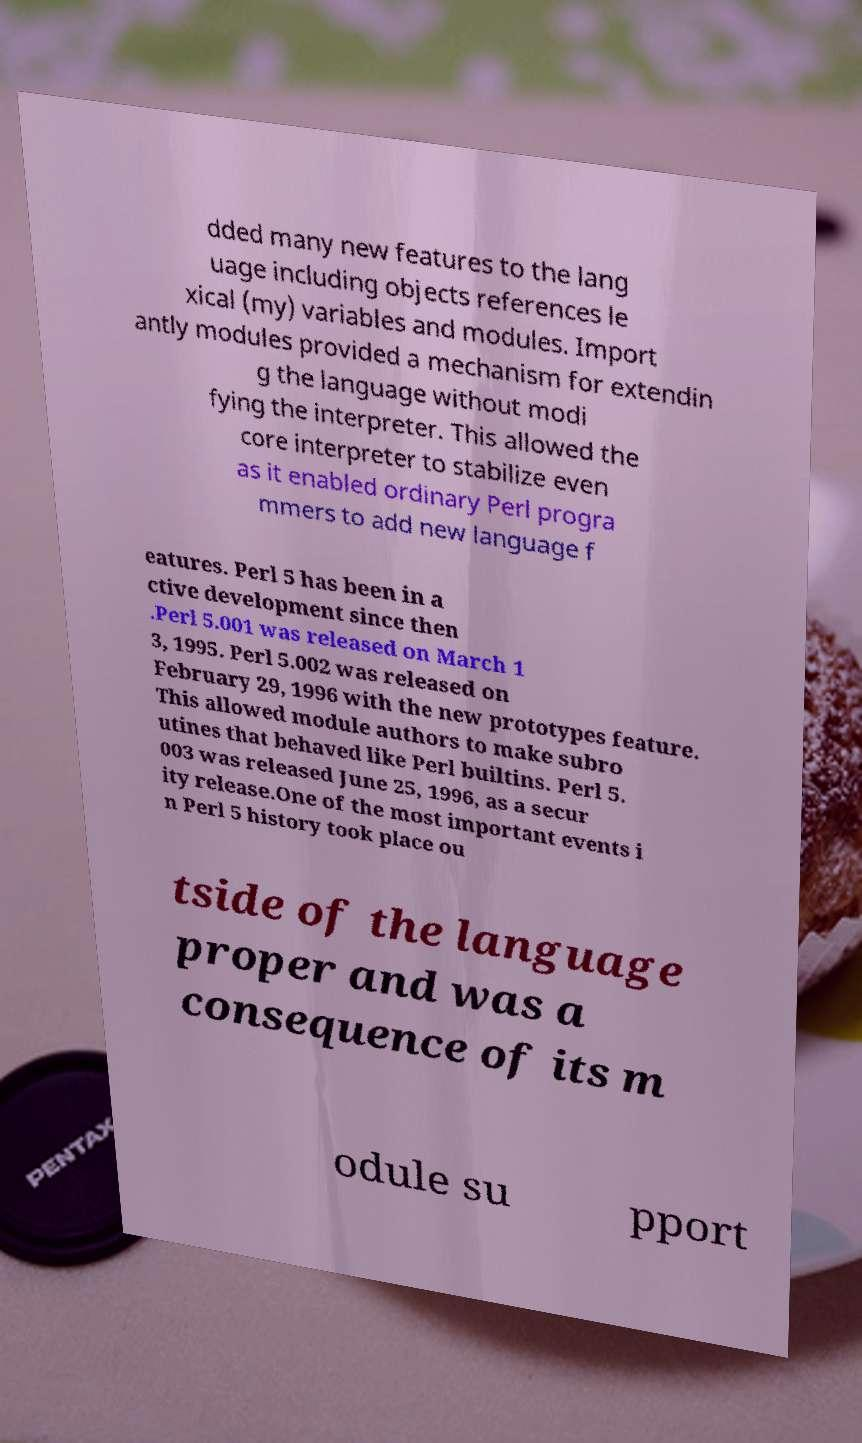I need the written content from this picture converted into text. Can you do that? dded many new features to the lang uage including objects references le xical (my) variables and modules. Import antly modules provided a mechanism for extendin g the language without modi fying the interpreter. This allowed the core interpreter to stabilize even as it enabled ordinary Perl progra mmers to add new language f eatures. Perl 5 has been in a ctive development since then .Perl 5.001 was released on March 1 3, 1995. Perl 5.002 was released on February 29, 1996 with the new prototypes feature. This allowed module authors to make subro utines that behaved like Perl builtins. Perl 5. 003 was released June 25, 1996, as a secur ity release.One of the most important events i n Perl 5 history took place ou tside of the language proper and was a consequence of its m odule su pport 